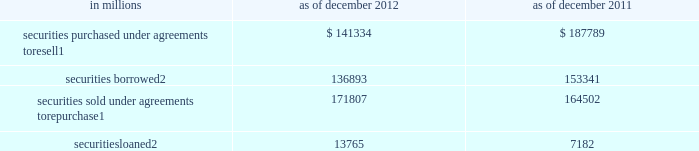Notes to consolidated financial statements note 9 .
Collateralized agreements and financings collateralized agreements are securities purchased under agreements to resell ( resale agreements or reverse repurchase agreements ) and securities borrowed .
Collateralized financings are securities sold under agreements to repurchase ( repurchase agreements ) , securities loaned and other secured financings .
The firm enters into these transactions in order to , among other things , facilitate client activities , invest excess cash , acquire securities to cover short positions and finance certain firm activities .
Collateralized agreements and financings are presented on a net-by-counterparty basis when a legal right of setoff exists .
Interest on collateralized agreements and collateralized financings is recognized over the life of the transaction and included in 201cinterest income 201d and 201cinterest expense , 201d respectively .
See note 23 for further information about interest income and interest expense .
The table below presents the carrying value of resale and repurchase agreements and securities borrowed and loaned transactions. .
In millions 2012 2011 securities purchased under agreements to resell 1 $ 141334 $ 187789 securities borrowed 2 136893 153341 securities sold under agreements to repurchase 1 171807 164502 securities loaned 2 13765 7182 1 .
Substantially all resale and repurchase agreements are carried at fair value under the fair value option .
See note 8 for further information about the valuation techniques and significant inputs used to determine fair value .
As of december 2012 and december 2011 , $ 38.40 billion and $ 47.62 billion of securities borrowed , and $ 1.56 billion and $ 107 million of securities loaned were at fair value , respectively .
Resale and repurchase agreements a resale agreement is a transaction in which the firm purchases financial instruments from a seller , typically in exchange for cash , and simultaneously enters into an agreement to resell the same or substantially the same financial instruments to the seller at a stated price plus accrued interest at a future date .
A repurchase agreement is a transaction in which the firm sells financial instruments to a buyer , typically in exchange for cash , and simultaneously enters into an agreement to repurchase the same or substantially the same financial instruments from the buyer at a stated price plus accrued interest at a future date .
The financial instruments purchased or sold in resale and repurchase agreements typically include u.s .
Government and federal agency , and investment-grade sovereign obligations .
The firm receives financial instruments purchased under resale agreements , makes delivery of financial instruments sold under repurchase agreements , monitors the market value of these financial instruments on a daily basis , and delivers or obtains additional collateral due to changes in the market value of the financial instruments , as appropriate .
For resale agreements , the firm typically requires delivery of collateral with a fair value approximately equal to the carrying value of the relevant assets in the consolidated statements of financial condition .
Even though repurchase and resale agreements involve the legal transfer of ownership of financial instruments , they are accounted for as financing arrangements because they require the financial instruments to be repurchased or resold at the maturity of the agreement .
However , 201crepos to maturity 201d are accounted for as sales .
A repo to maturity is a transaction in which the firm transfers a security under an agreement to repurchase the security where the maturity date of the repurchase agreement matches the maturity date of the underlying security .
Therefore , the firm effectively no longer has a repurchase obligation and has relinquished control over the underlying security and , accordingly , accounts for the transaction as a sale .
The firm had no repos to maturity outstanding as of december 2012 or december 2011 .
152 goldman sachs 2012 annual report .
Between december 2012 and december 2011 , what was the change in billions in the amount of securities borrowed? 
Computations: (38.40 - 47.62)
Answer: -9.22. 